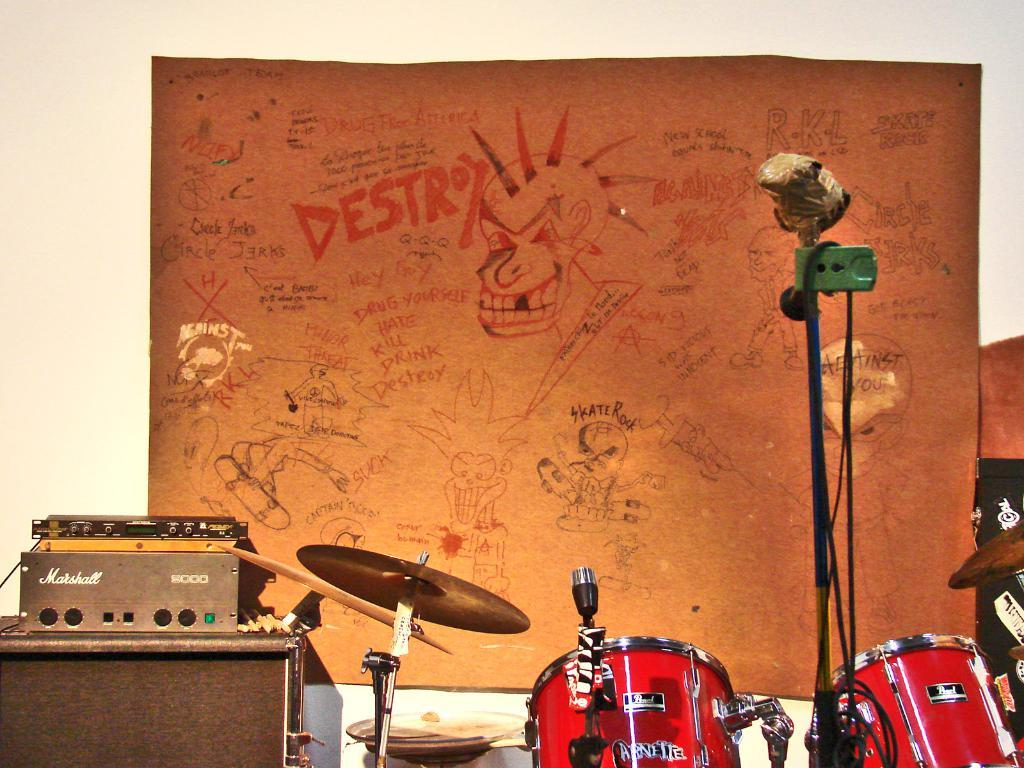What can be seen in the image related to music? There are musical instruments in the image. What is the color and location of the object attached to the wall? There is an orange color object attached to a wall in the image. What is written on the orange object? There is writing on the orange object. What kind of artwork is present on the orange object? There is a drawing on the orange object. What type of industry is depicted in the image? There is no industry depicted in the image; it features musical instruments and an orange object with writing and a drawing. What role does the nail play in the image? There is no mention of a nail in the image; it focuses on musical instruments, an orange object, and its contents. 